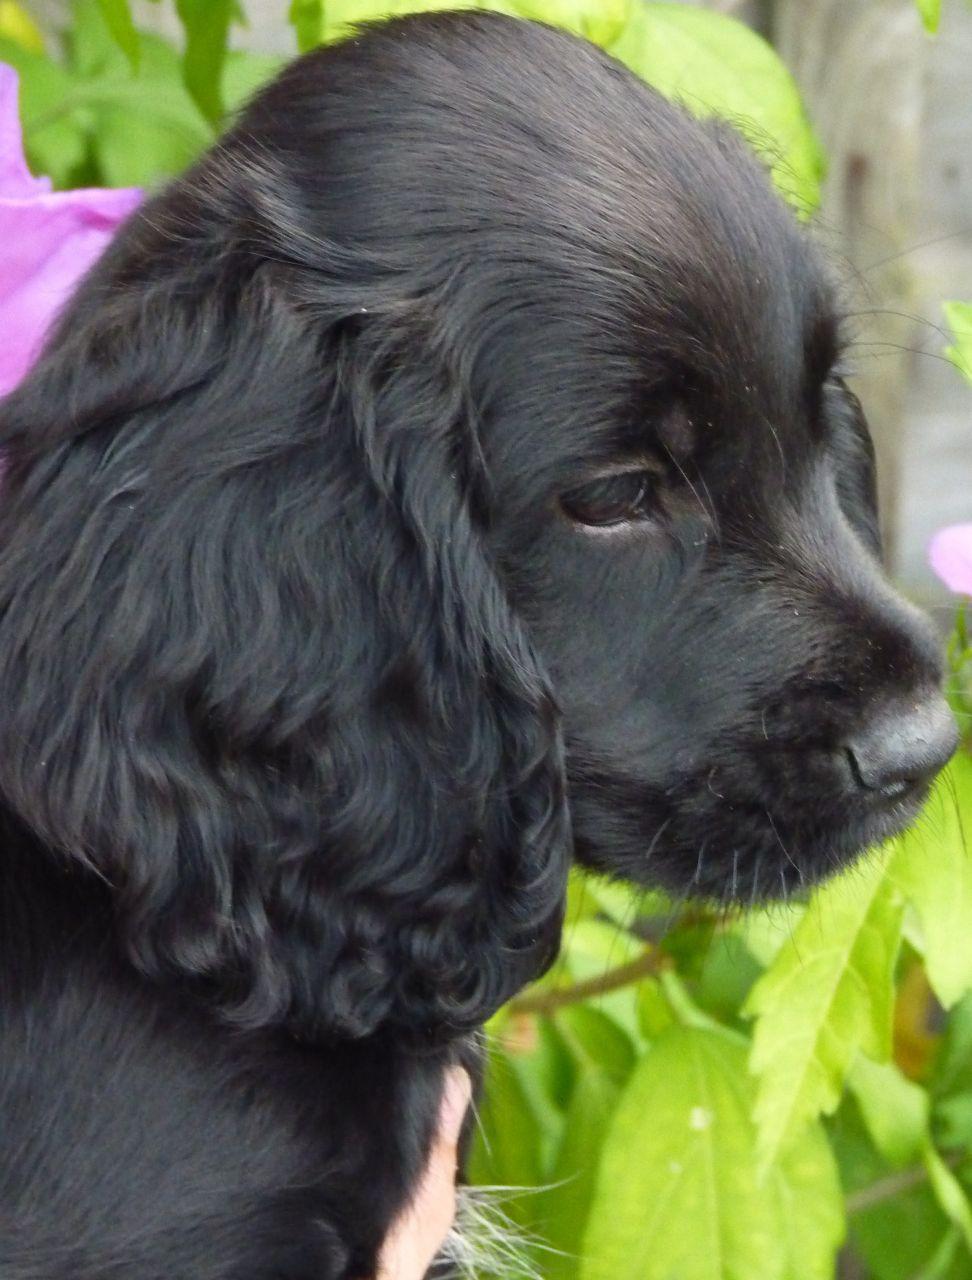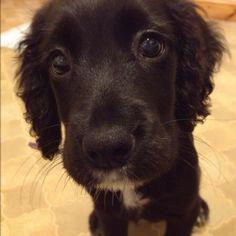The first image is the image on the left, the second image is the image on the right. For the images displayed, is the sentence "The black dog in the image on the left is outside on a sunny day." factually correct? Answer yes or no. Yes. The first image is the image on the left, the second image is the image on the right. Given the left and right images, does the statement "There are more black dogs in the right image than in the left." hold true? Answer yes or no. No. 